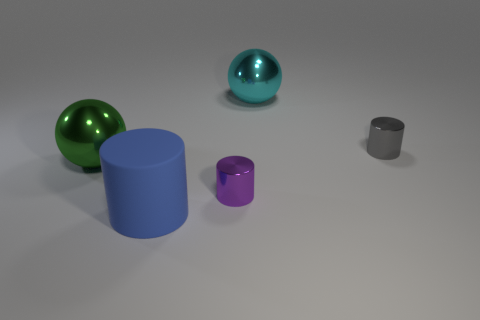Subtract all yellow cylinders. Subtract all blue balls. How many cylinders are left? 3 Add 2 yellow rubber things. How many objects exist? 7 Subtract all cylinders. How many objects are left? 2 Add 2 big metallic spheres. How many big metallic spheres are left? 4 Add 3 matte cylinders. How many matte cylinders exist? 4 Subtract 1 cyan balls. How many objects are left? 4 Subtract all metal cylinders. Subtract all big green things. How many objects are left? 2 